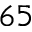Convert formula to latex. <formula><loc_0><loc_0><loc_500><loc_500>^ { 6 5 }</formula> 